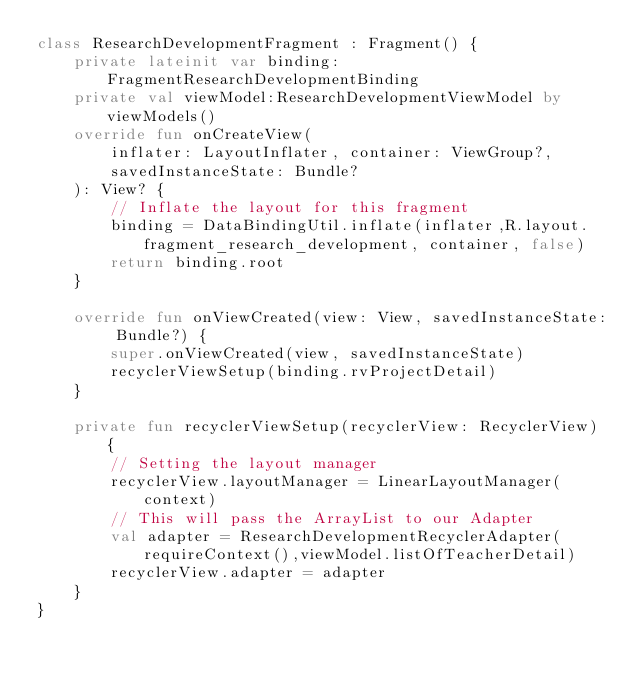Convert code to text. <code><loc_0><loc_0><loc_500><loc_500><_Kotlin_>class ResearchDevelopmentFragment : Fragment() {
    private lateinit var binding:FragmentResearchDevelopmentBinding
    private val viewModel:ResearchDevelopmentViewModel by viewModels()
    override fun onCreateView(
        inflater: LayoutInflater, container: ViewGroup?,
        savedInstanceState: Bundle?
    ): View? {
        // Inflate the layout for this fragment
        binding = DataBindingUtil.inflate(inflater,R.layout.fragment_research_development, container, false)
        return binding.root
    }

    override fun onViewCreated(view: View, savedInstanceState: Bundle?) {
        super.onViewCreated(view, savedInstanceState)
        recyclerViewSetup(binding.rvProjectDetail)
    }

    private fun recyclerViewSetup(recyclerView: RecyclerView) {
        // Setting the layout manager
        recyclerView.layoutManager = LinearLayoutManager(context)
        // This will pass the ArrayList to our Adapter
        val adapter = ResearchDevelopmentRecyclerAdapter(requireContext(),viewModel.listOfTeacherDetail)
        recyclerView.adapter = adapter
    }
}</code> 